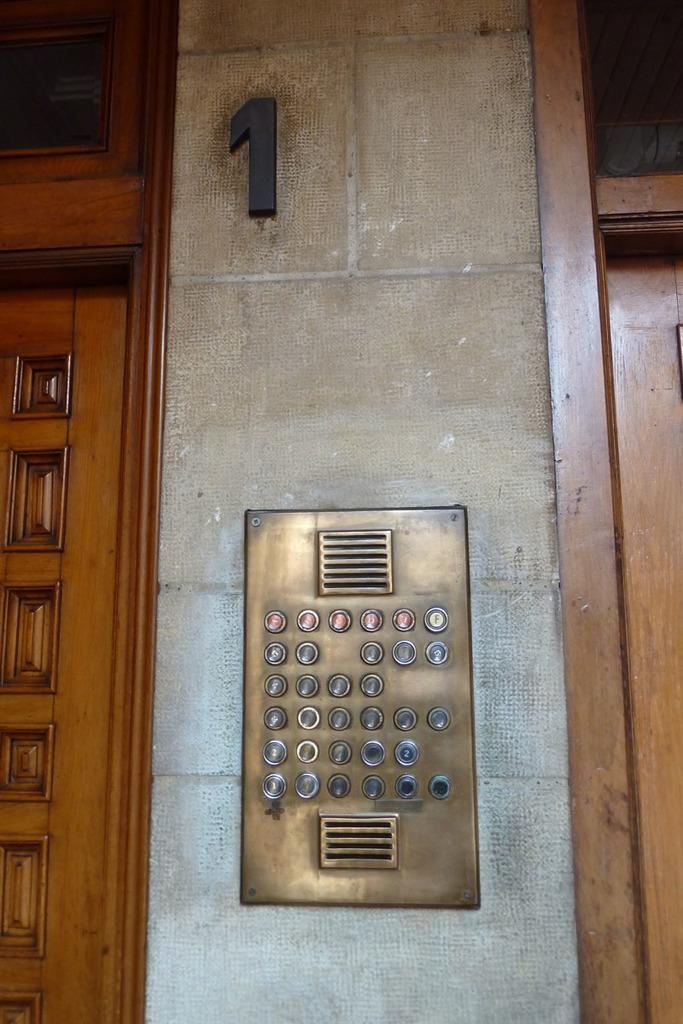What is located in the middle of the picture? There are buttons in the middle of the picture. What can be seen at the top of the picture? There is a number visible in the top of the picture. What type of material is featured on the left side of the picture? There is a design on the wood on the left side of the picture. Can you describe the rainstorm happening outside the hall in the image? There is no rainstorm or hall present in the image; it features buttons, a number, and a design on wood. 